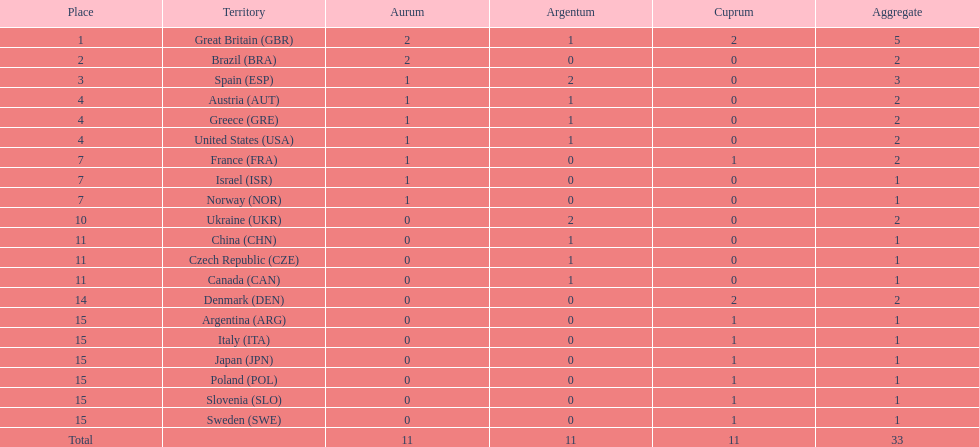What was the number of silver medals won by ukraine? 2. 